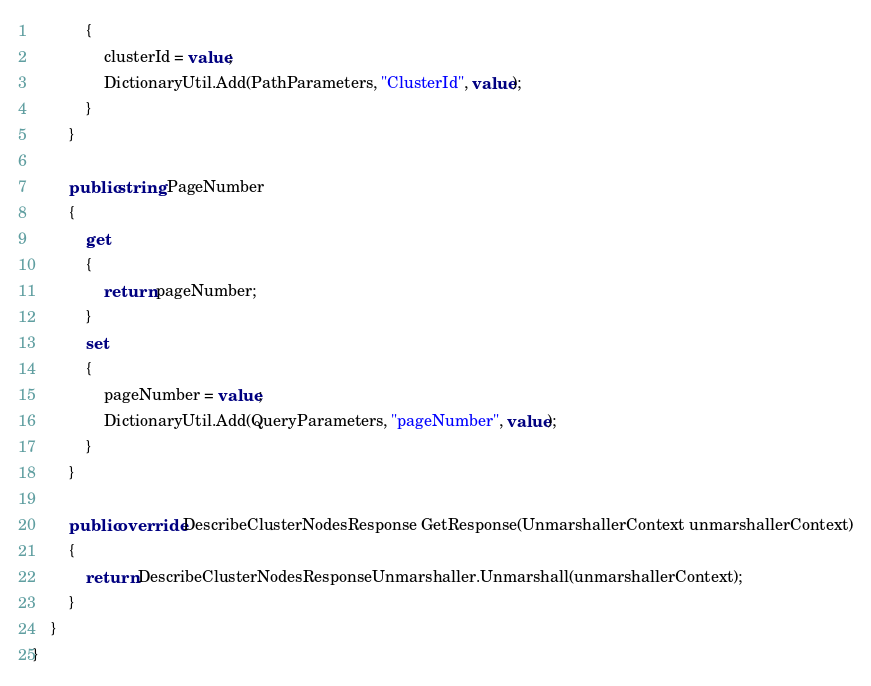<code> <loc_0><loc_0><loc_500><loc_500><_C#_>			{
				clusterId = value;
				DictionaryUtil.Add(PathParameters, "ClusterId", value);
			}
		}

		public string PageNumber
		{
			get
			{
				return pageNumber;
			}
			set	
			{
				pageNumber = value;
				DictionaryUtil.Add(QueryParameters, "pageNumber", value);
			}
		}

        public override DescribeClusterNodesResponse GetResponse(UnmarshallerContext unmarshallerContext)
        {
            return DescribeClusterNodesResponseUnmarshaller.Unmarshall(unmarshallerContext);
        }
    }
}
</code> 